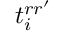Convert formula to latex. <formula><loc_0><loc_0><loc_500><loc_500>t _ { i } ^ { r r ^ { \prime } }</formula> 